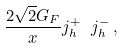<formula> <loc_0><loc_0><loc_500><loc_500>\frac { 2 \sqrt { 2 } G _ { F } } x j _ { h } ^ { + } \ j _ { h } ^ { - } \, ,</formula> 